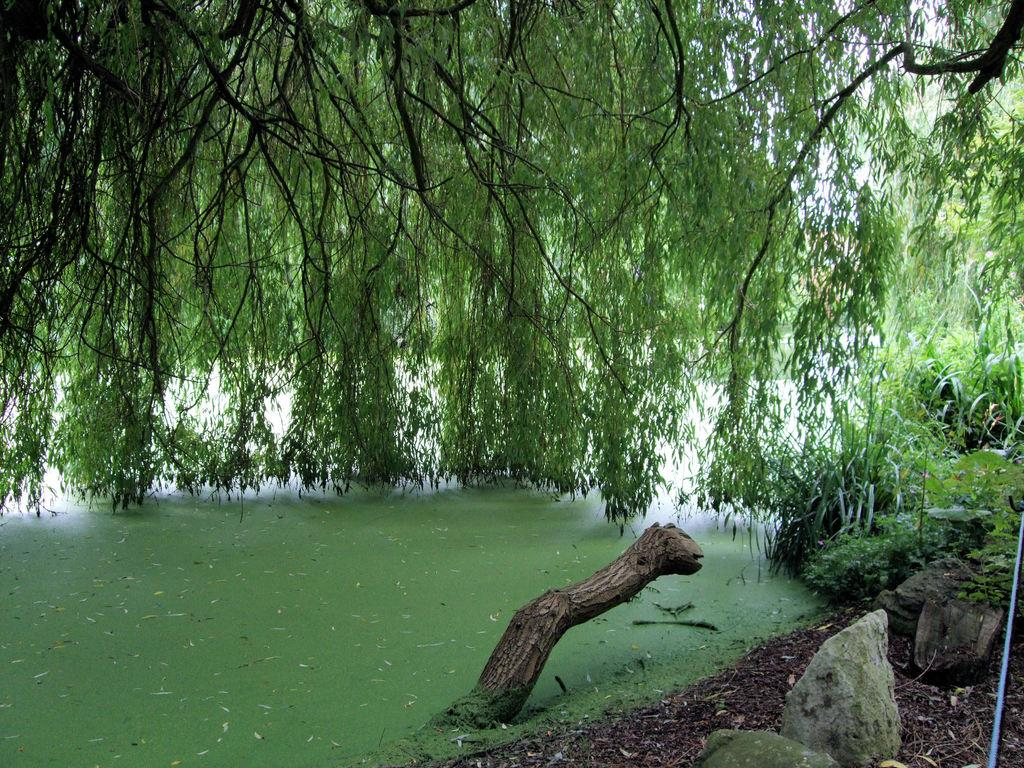What is present at the bottom of the image? There are stones, water, and plants at the bottom of the image. What can be found in the middle of the image? There are trees in the middle of the image. How many bikes are visible in the image? There are no bikes present in the image. What type of bird can be seen flying in the image? There is no bird visible in the image. 